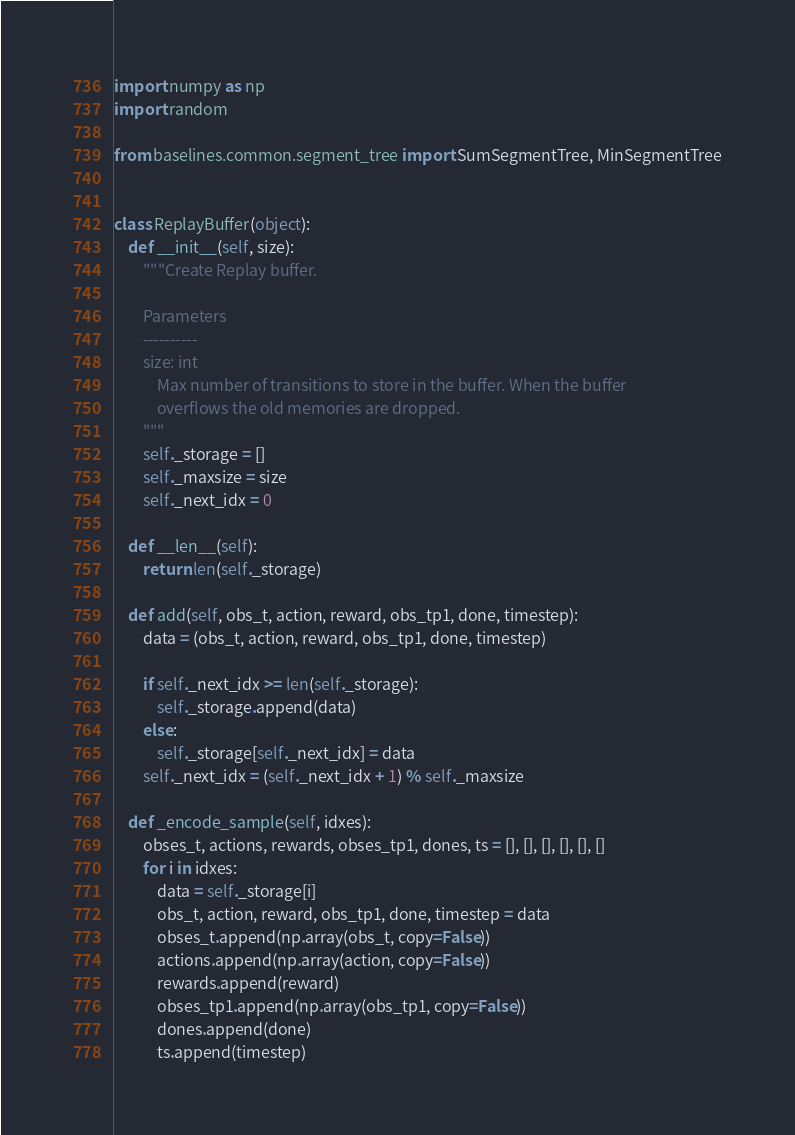<code> <loc_0><loc_0><loc_500><loc_500><_Python_>import numpy as np
import random

from baselines.common.segment_tree import SumSegmentTree, MinSegmentTree


class ReplayBuffer(object):
    def __init__(self, size):
        """Create Replay buffer.

        Parameters
        ----------
        size: int
            Max number of transitions to store in the buffer. When the buffer
            overflows the old memories are dropped.
        """
        self._storage = []
        self._maxsize = size
        self._next_idx = 0

    def __len__(self):
        return len(self._storage)

    def add(self, obs_t, action, reward, obs_tp1, done, timestep):
        data = (obs_t, action, reward, obs_tp1, done, timestep)

        if self._next_idx >= len(self._storage):
            self._storage.append(data)
        else:
            self._storage[self._next_idx] = data
        self._next_idx = (self._next_idx + 1) % self._maxsize

    def _encode_sample(self, idxes):
        obses_t, actions, rewards, obses_tp1, dones, ts = [], [], [], [], [], []
        for i in idxes:
            data = self._storage[i]
            obs_t, action, reward, obs_tp1, done, timestep = data
            obses_t.append(np.array(obs_t, copy=False))
            actions.append(np.array(action, copy=False))
            rewards.append(reward)
            obses_tp1.append(np.array(obs_tp1, copy=False))
            dones.append(done)
            ts.append(timestep)</code> 